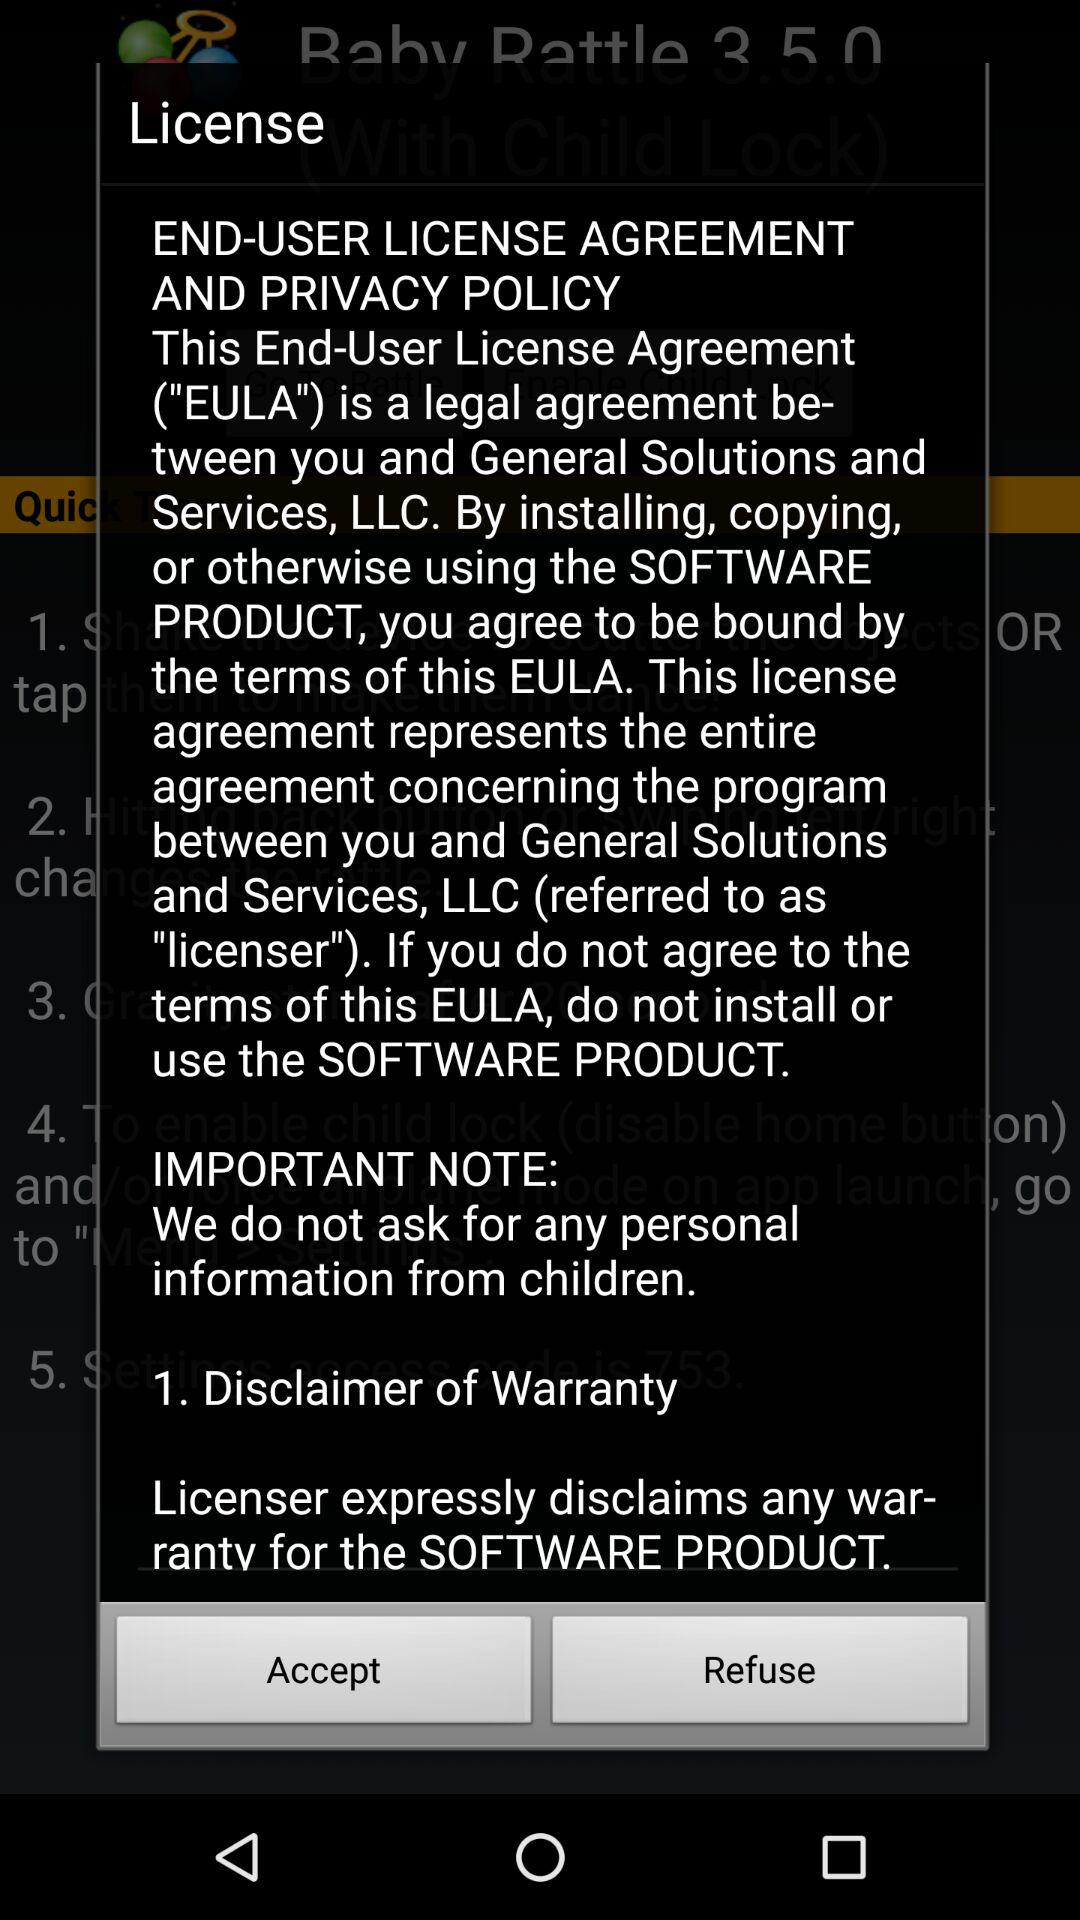What is the privacy policy? The privacy policy is "This End-User License Agreement ("EULA") is a legal agreement be tween you and General Solutions and Services, LLC. By installing, copying, jor otherwise using the SOFTWARE 1. PRODUCT, you agree to be bound by the terms of this EULA. This license agreement represents the entire agreement concerning the program between you and General Solutions and Services, LLC (referred to as "licenser"). If you do not agree to the terms of this EULA, do not install or use the SOFTWARE PRODUCT". 